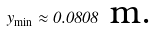Convert formula to latex. <formula><loc_0><loc_0><loc_500><loc_500>y _ { \min } \approx 0 . 0 8 0 8 \text { m.}</formula> 